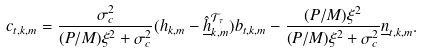Convert formula to latex. <formula><loc_0><loc_0><loc_500><loc_500>c _ { t , k , m } = \frac { \sigma _ { c } ^ { 2 } } { ( P / M ) \xi ^ { 2 } + \sigma _ { c } ^ { 2 } } ( h _ { k , m } - \underline { \hat { h } } _ { k , m } ^ { \mathcal { T } _ { \tau } } ) b _ { t , k , m } - \frac { ( P / M ) \xi ^ { 2 } } { ( P / M ) \xi ^ { 2 } + \sigma _ { c } ^ { 2 } } \underline { n } _ { t , k , m } .</formula> 